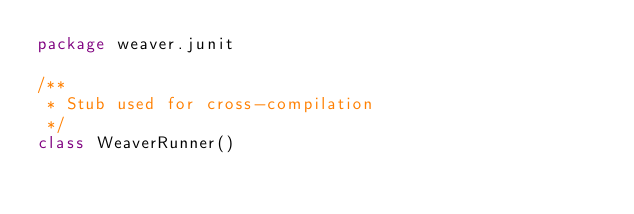Convert code to text. <code><loc_0><loc_0><loc_500><loc_500><_Scala_>package weaver.junit

/**
 * Stub used for cross-compilation
 */
class WeaverRunner()
</code> 